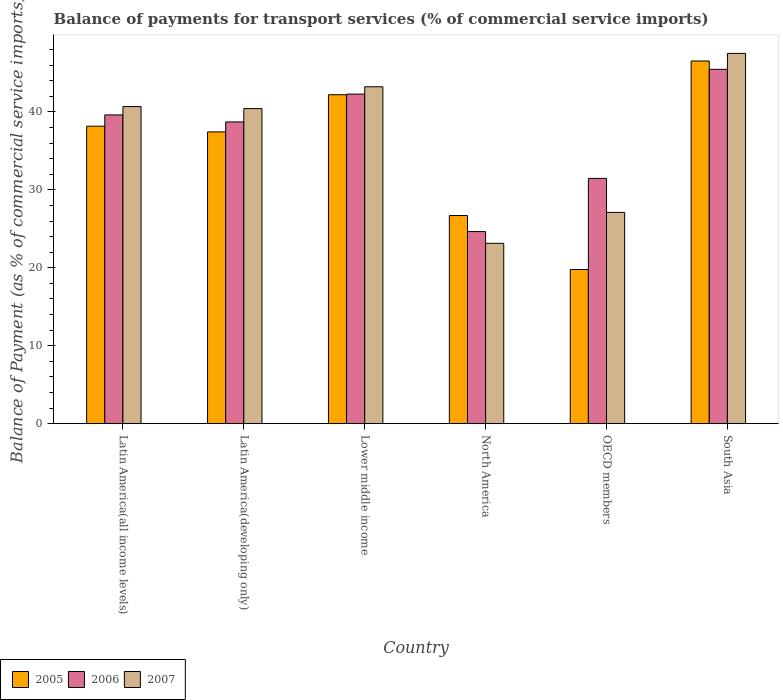Are the number of bars on each tick of the X-axis equal?
Offer a terse response. Yes. How many bars are there on the 6th tick from the left?
Offer a terse response. 3. How many bars are there on the 6th tick from the right?
Your response must be concise. 3. What is the balance of payments for transport services in 2007 in OECD members?
Make the answer very short. 27.11. Across all countries, what is the maximum balance of payments for transport services in 2007?
Provide a short and direct response. 47.5. Across all countries, what is the minimum balance of payments for transport services in 2006?
Make the answer very short. 24.65. In which country was the balance of payments for transport services in 2005 maximum?
Your answer should be compact. South Asia. What is the total balance of payments for transport services in 2005 in the graph?
Provide a short and direct response. 210.81. What is the difference between the balance of payments for transport services in 2006 in Lower middle income and that in OECD members?
Offer a terse response. 10.81. What is the difference between the balance of payments for transport services in 2006 in OECD members and the balance of payments for transport services in 2005 in Latin America(all income levels)?
Ensure brevity in your answer.  -6.7. What is the average balance of payments for transport services in 2005 per country?
Make the answer very short. 35.14. What is the difference between the balance of payments for transport services of/in 2006 and balance of payments for transport services of/in 2005 in North America?
Offer a terse response. -2.06. What is the ratio of the balance of payments for transport services in 2007 in Latin America(all income levels) to that in OECD members?
Give a very brief answer. 1.5. What is the difference between the highest and the second highest balance of payments for transport services in 2005?
Offer a terse response. -4.04. What is the difference between the highest and the lowest balance of payments for transport services in 2005?
Your response must be concise. 26.74. What does the 2nd bar from the left in South Asia represents?
Your answer should be compact. 2006. What does the 3rd bar from the right in Latin America(developing only) represents?
Make the answer very short. 2005. Are all the bars in the graph horizontal?
Your answer should be compact. No. Are the values on the major ticks of Y-axis written in scientific E-notation?
Your answer should be very brief. No. Does the graph contain any zero values?
Keep it short and to the point. No. How many legend labels are there?
Provide a short and direct response. 3. How are the legend labels stacked?
Provide a succinct answer. Horizontal. What is the title of the graph?
Offer a terse response. Balance of payments for transport services (% of commercial service imports). What is the label or title of the X-axis?
Keep it short and to the point. Country. What is the label or title of the Y-axis?
Offer a very short reply. Balance of Payment (as % of commercial service imports). What is the Balance of Payment (as % of commercial service imports) in 2005 in Latin America(all income levels)?
Offer a very short reply. 38.16. What is the Balance of Payment (as % of commercial service imports) of 2006 in Latin America(all income levels)?
Your answer should be very brief. 39.61. What is the Balance of Payment (as % of commercial service imports) of 2007 in Latin America(all income levels)?
Offer a very short reply. 40.68. What is the Balance of Payment (as % of commercial service imports) in 2005 in Latin America(developing only)?
Your answer should be very brief. 37.43. What is the Balance of Payment (as % of commercial service imports) of 2006 in Latin America(developing only)?
Offer a terse response. 38.71. What is the Balance of Payment (as % of commercial service imports) of 2007 in Latin America(developing only)?
Make the answer very short. 40.42. What is the Balance of Payment (as % of commercial service imports) in 2005 in Lower middle income?
Ensure brevity in your answer.  42.2. What is the Balance of Payment (as % of commercial service imports) of 2006 in Lower middle income?
Ensure brevity in your answer.  42.28. What is the Balance of Payment (as % of commercial service imports) in 2007 in Lower middle income?
Offer a very short reply. 43.22. What is the Balance of Payment (as % of commercial service imports) in 2005 in North America?
Provide a short and direct response. 26.71. What is the Balance of Payment (as % of commercial service imports) of 2006 in North America?
Offer a terse response. 24.65. What is the Balance of Payment (as % of commercial service imports) of 2007 in North America?
Provide a succinct answer. 23.14. What is the Balance of Payment (as % of commercial service imports) in 2005 in OECD members?
Your response must be concise. 19.78. What is the Balance of Payment (as % of commercial service imports) in 2006 in OECD members?
Offer a terse response. 31.47. What is the Balance of Payment (as % of commercial service imports) in 2007 in OECD members?
Your answer should be compact. 27.11. What is the Balance of Payment (as % of commercial service imports) of 2005 in South Asia?
Your response must be concise. 46.53. What is the Balance of Payment (as % of commercial service imports) in 2006 in South Asia?
Make the answer very short. 45.46. What is the Balance of Payment (as % of commercial service imports) of 2007 in South Asia?
Keep it short and to the point. 47.5. Across all countries, what is the maximum Balance of Payment (as % of commercial service imports) of 2005?
Your answer should be very brief. 46.53. Across all countries, what is the maximum Balance of Payment (as % of commercial service imports) in 2006?
Offer a very short reply. 45.46. Across all countries, what is the maximum Balance of Payment (as % of commercial service imports) in 2007?
Your response must be concise. 47.5. Across all countries, what is the minimum Balance of Payment (as % of commercial service imports) in 2005?
Offer a terse response. 19.78. Across all countries, what is the minimum Balance of Payment (as % of commercial service imports) of 2006?
Your response must be concise. 24.65. Across all countries, what is the minimum Balance of Payment (as % of commercial service imports) of 2007?
Ensure brevity in your answer.  23.14. What is the total Balance of Payment (as % of commercial service imports) of 2005 in the graph?
Offer a terse response. 210.81. What is the total Balance of Payment (as % of commercial service imports) in 2006 in the graph?
Your response must be concise. 222.17. What is the total Balance of Payment (as % of commercial service imports) in 2007 in the graph?
Keep it short and to the point. 222.07. What is the difference between the Balance of Payment (as % of commercial service imports) in 2005 in Latin America(all income levels) and that in Latin America(developing only)?
Offer a very short reply. 0.73. What is the difference between the Balance of Payment (as % of commercial service imports) in 2006 in Latin America(all income levels) and that in Latin America(developing only)?
Your answer should be very brief. 0.9. What is the difference between the Balance of Payment (as % of commercial service imports) of 2007 in Latin America(all income levels) and that in Latin America(developing only)?
Your answer should be very brief. 0.26. What is the difference between the Balance of Payment (as % of commercial service imports) in 2005 in Latin America(all income levels) and that in Lower middle income?
Offer a terse response. -4.04. What is the difference between the Balance of Payment (as % of commercial service imports) in 2006 in Latin America(all income levels) and that in Lower middle income?
Your answer should be very brief. -2.67. What is the difference between the Balance of Payment (as % of commercial service imports) in 2007 in Latin America(all income levels) and that in Lower middle income?
Offer a terse response. -2.54. What is the difference between the Balance of Payment (as % of commercial service imports) of 2005 in Latin America(all income levels) and that in North America?
Your response must be concise. 11.46. What is the difference between the Balance of Payment (as % of commercial service imports) of 2006 in Latin America(all income levels) and that in North America?
Your response must be concise. 14.96. What is the difference between the Balance of Payment (as % of commercial service imports) in 2007 in Latin America(all income levels) and that in North America?
Your answer should be very brief. 17.54. What is the difference between the Balance of Payment (as % of commercial service imports) of 2005 in Latin America(all income levels) and that in OECD members?
Your answer should be very brief. 18.38. What is the difference between the Balance of Payment (as % of commercial service imports) in 2006 in Latin America(all income levels) and that in OECD members?
Offer a terse response. 8.14. What is the difference between the Balance of Payment (as % of commercial service imports) in 2007 in Latin America(all income levels) and that in OECD members?
Offer a very short reply. 13.57. What is the difference between the Balance of Payment (as % of commercial service imports) in 2005 in Latin America(all income levels) and that in South Asia?
Provide a succinct answer. -8.36. What is the difference between the Balance of Payment (as % of commercial service imports) of 2006 in Latin America(all income levels) and that in South Asia?
Your answer should be very brief. -5.85. What is the difference between the Balance of Payment (as % of commercial service imports) of 2007 in Latin America(all income levels) and that in South Asia?
Provide a short and direct response. -6.82. What is the difference between the Balance of Payment (as % of commercial service imports) of 2005 in Latin America(developing only) and that in Lower middle income?
Give a very brief answer. -4.77. What is the difference between the Balance of Payment (as % of commercial service imports) in 2006 in Latin America(developing only) and that in Lower middle income?
Give a very brief answer. -3.57. What is the difference between the Balance of Payment (as % of commercial service imports) in 2007 in Latin America(developing only) and that in Lower middle income?
Your answer should be very brief. -2.8. What is the difference between the Balance of Payment (as % of commercial service imports) of 2005 in Latin America(developing only) and that in North America?
Your answer should be very brief. 10.73. What is the difference between the Balance of Payment (as % of commercial service imports) of 2006 in Latin America(developing only) and that in North America?
Ensure brevity in your answer.  14.06. What is the difference between the Balance of Payment (as % of commercial service imports) in 2007 in Latin America(developing only) and that in North America?
Ensure brevity in your answer.  17.28. What is the difference between the Balance of Payment (as % of commercial service imports) in 2005 in Latin America(developing only) and that in OECD members?
Keep it short and to the point. 17.65. What is the difference between the Balance of Payment (as % of commercial service imports) in 2006 in Latin America(developing only) and that in OECD members?
Your response must be concise. 7.24. What is the difference between the Balance of Payment (as % of commercial service imports) in 2007 in Latin America(developing only) and that in OECD members?
Your response must be concise. 13.31. What is the difference between the Balance of Payment (as % of commercial service imports) of 2005 in Latin America(developing only) and that in South Asia?
Give a very brief answer. -9.09. What is the difference between the Balance of Payment (as % of commercial service imports) in 2006 in Latin America(developing only) and that in South Asia?
Make the answer very short. -6.75. What is the difference between the Balance of Payment (as % of commercial service imports) of 2007 in Latin America(developing only) and that in South Asia?
Give a very brief answer. -7.08. What is the difference between the Balance of Payment (as % of commercial service imports) in 2005 in Lower middle income and that in North America?
Offer a very short reply. 15.49. What is the difference between the Balance of Payment (as % of commercial service imports) of 2006 in Lower middle income and that in North America?
Your answer should be compact. 17.63. What is the difference between the Balance of Payment (as % of commercial service imports) of 2007 in Lower middle income and that in North America?
Make the answer very short. 20.08. What is the difference between the Balance of Payment (as % of commercial service imports) in 2005 in Lower middle income and that in OECD members?
Make the answer very short. 22.42. What is the difference between the Balance of Payment (as % of commercial service imports) of 2006 in Lower middle income and that in OECD members?
Offer a terse response. 10.81. What is the difference between the Balance of Payment (as % of commercial service imports) of 2007 in Lower middle income and that in OECD members?
Offer a terse response. 16.11. What is the difference between the Balance of Payment (as % of commercial service imports) in 2005 in Lower middle income and that in South Asia?
Your response must be concise. -4.32. What is the difference between the Balance of Payment (as % of commercial service imports) in 2006 in Lower middle income and that in South Asia?
Keep it short and to the point. -3.18. What is the difference between the Balance of Payment (as % of commercial service imports) in 2007 in Lower middle income and that in South Asia?
Offer a very short reply. -4.28. What is the difference between the Balance of Payment (as % of commercial service imports) in 2005 in North America and that in OECD members?
Your answer should be compact. 6.93. What is the difference between the Balance of Payment (as % of commercial service imports) in 2006 in North America and that in OECD members?
Give a very brief answer. -6.82. What is the difference between the Balance of Payment (as % of commercial service imports) of 2007 in North America and that in OECD members?
Provide a short and direct response. -3.97. What is the difference between the Balance of Payment (as % of commercial service imports) in 2005 in North America and that in South Asia?
Provide a succinct answer. -19.82. What is the difference between the Balance of Payment (as % of commercial service imports) of 2006 in North America and that in South Asia?
Make the answer very short. -20.81. What is the difference between the Balance of Payment (as % of commercial service imports) in 2007 in North America and that in South Asia?
Provide a short and direct response. -24.36. What is the difference between the Balance of Payment (as % of commercial service imports) of 2005 in OECD members and that in South Asia?
Give a very brief answer. -26.74. What is the difference between the Balance of Payment (as % of commercial service imports) in 2006 in OECD members and that in South Asia?
Keep it short and to the point. -13.99. What is the difference between the Balance of Payment (as % of commercial service imports) in 2007 in OECD members and that in South Asia?
Give a very brief answer. -20.39. What is the difference between the Balance of Payment (as % of commercial service imports) of 2005 in Latin America(all income levels) and the Balance of Payment (as % of commercial service imports) of 2006 in Latin America(developing only)?
Provide a short and direct response. -0.55. What is the difference between the Balance of Payment (as % of commercial service imports) in 2005 in Latin America(all income levels) and the Balance of Payment (as % of commercial service imports) in 2007 in Latin America(developing only)?
Offer a terse response. -2.26. What is the difference between the Balance of Payment (as % of commercial service imports) of 2006 in Latin America(all income levels) and the Balance of Payment (as % of commercial service imports) of 2007 in Latin America(developing only)?
Your answer should be very brief. -0.81. What is the difference between the Balance of Payment (as % of commercial service imports) of 2005 in Latin America(all income levels) and the Balance of Payment (as % of commercial service imports) of 2006 in Lower middle income?
Your response must be concise. -4.11. What is the difference between the Balance of Payment (as % of commercial service imports) of 2005 in Latin America(all income levels) and the Balance of Payment (as % of commercial service imports) of 2007 in Lower middle income?
Ensure brevity in your answer.  -5.06. What is the difference between the Balance of Payment (as % of commercial service imports) of 2006 in Latin America(all income levels) and the Balance of Payment (as % of commercial service imports) of 2007 in Lower middle income?
Your answer should be compact. -3.61. What is the difference between the Balance of Payment (as % of commercial service imports) of 2005 in Latin America(all income levels) and the Balance of Payment (as % of commercial service imports) of 2006 in North America?
Make the answer very short. 13.52. What is the difference between the Balance of Payment (as % of commercial service imports) in 2005 in Latin America(all income levels) and the Balance of Payment (as % of commercial service imports) in 2007 in North America?
Provide a short and direct response. 15.02. What is the difference between the Balance of Payment (as % of commercial service imports) in 2006 in Latin America(all income levels) and the Balance of Payment (as % of commercial service imports) in 2007 in North America?
Your answer should be very brief. 16.47. What is the difference between the Balance of Payment (as % of commercial service imports) in 2005 in Latin America(all income levels) and the Balance of Payment (as % of commercial service imports) in 2006 in OECD members?
Make the answer very short. 6.7. What is the difference between the Balance of Payment (as % of commercial service imports) in 2005 in Latin America(all income levels) and the Balance of Payment (as % of commercial service imports) in 2007 in OECD members?
Your answer should be very brief. 11.06. What is the difference between the Balance of Payment (as % of commercial service imports) in 2006 in Latin America(all income levels) and the Balance of Payment (as % of commercial service imports) in 2007 in OECD members?
Your answer should be compact. 12.5. What is the difference between the Balance of Payment (as % of commercial service imports) in 2005 in Latin America(all income levels) and the Balance of Payment (as % of commercial service imports) in 2006 in South Asia?
Keep it short and to the point. -7.29. What is the difference between the Balance of Payment (as % of commercial service imports) of 2005 in Latin America(all income levels) and the Balance of Payment (as % of commercial service imports) of 2007 in South Asia?
Your response must be concise. -9.34. What is the difference between the Balance of Payment (as % of commercial service imports) of 2006 in Latin America(all income levels) and the Balance of Payment (as % of commercial service imports) of 2007 in South Asia?
Your answer should be compact. -7.89. What is the difference between the Balance of Payment (as % of commercial service imports) of 2005 in Latin America(developing only) and the Balance of Payment (as % of commercial service imports) of 2006 in Lower middle income?
Keep it short and to the point. -4.84. What is the difference between the Balance of Payment (as % of commercial service imports) in 2005 in Latin America(developing only) and the Balance of Payment (as % of commercial service imports) in 2007 in Lower middle income?
Provide a succinct answer. -5.79. What is the difference between the Balance of Payment (as % of commercial service imports) of 2006 in Latin America(developing only) and the Balance of Payment (as % of commercial service imports) of 2007 in Lower middle income?
Your answer should be very brief. -4.51. What is the difference between the Balance of Payment (as % of commercial service imports) in 2005 in Latin America(developing only) and the Balance of Payment (as % of commercial service imports) in 2006 in North America?
Make the answer very short. 12.79. What is the difference between the Balance of Payment (as % of commercial service imports) of 2005 in Latin America(developing only) and the Balance of Payment (as % of commercial service imports) of 2007 in North America?
Your response must be concise. 14.29. What is the difference between the Balance of Payment (as % of commercial service imports) in 2006 in Latin America(developing only) and the Balance of Payment (as % of commercial service imports) in 2007 in North America?
Offer a very short reply. 15.57. What is the difference between the Balance of Payment (as % of commercial service imports) of 2005 in Latin America(developing only) and the Balance of Payment (as % of commercial service imports) of 2006 in OECD members?
Ensure brevity in your answer.  5.96. What is the difference between the Balance of Payment (as % of commercial service imports) of 2005 in Latin America(developing only) and the Balance of Payment (as % of commercial service imports) of 2007 in OECD members?
Make the answer very short. 10.33. What is the difference between the Balance of Payment (as % of commercial service imports) in 2006 in Latin America(developing only) and the Balance of Payment (as % of commercial service imports) in 2007 in OECD members?
Ensure brevity in your answer.  11.6. What is the difference between the Balance of Payment (as % of commercial service imports) of 2005 in Latin America(developing only) and the Balance of Payment (as % of commercial service imports) of 2006 in South Asia?
Offer a terse response. -8.02. What is the difference between the Balance of Payment (as % of commercial service imports) in 2005 in Latin America(developing only) and the Balance of Payment (as % of commercial service imports) in 2007 in South Asia?
Give a very brief answer. -10.07. What is the difference between the Balance of Payment (as % of commercial service imports) in 2006 in Latin America(developing only) and the Balance of Payment (as % of commercial service imports) in 2007 in South Asia?
Your answer should be compact. -8.79. What is the difference between the Balance of Payment (as % of commercial service imports) in 2005 in Lower middle income and the Balance of Payment (as % of commercial service imports) in 2006 in North America?
Provide a succinct answer. 17.55. What is the difference between the Balance of Payment (as % of commercial service imports) in 2005 in Lower middle income and the Balance of Payment (as % of commercial service imports) in 2007 in North America?
Your answer should be compact. 19.06. What is the difference between the Balance of Payment (as % of commercial service imports) in 2006 in Lower middle income and the Balance of Payment (as % of commercial service imports) in 2007 in North America?
Provide a succinct answer. 19.14. What is the difference between the Balance of Payment (as % of commercial service imports) in 2005 in Lower middle income and the Balance of Payment (as % of commercial service imports) in 2006 in OECD members?
Keep it short and to the point. 10.73. What is the difference between the Balance of Payment (as % of commercial service imports) in 2005 in Lower middle income and the Balance of Payment (as % of commercial service imports) in 2007 in OECD members?
Your answer should be compact. 15.09. What is the difference between the Balance of Payment (as % of commercial service imports) in 2006 in Lower middle income and the Balance of Payment (as % of commercial service imports) in 2007 in OECD members?
Provide a succinct answer. 15.17. What is the difference between the Balance of Payment (as % of commercial service imports) in 2005 in Lower middle income and the Balance of Payment (as % of commercial service imports) in 2006 in South Asia?
Keep it short and to the point. -3.26. What is the difference between the Balance of Payment (as % of commercial service imports) in 2005 in Lower middle income and the Balance of Payment (as % of commercial service imports) in 2007 in South Asia?
Your answer should be compact. -5.3. What is the difference between the Balance of Payment (as % of commercial service imports) in 2006 in Lower middle income and the Balance of Payment (as % of commercial service imports) in 2007 in South Asia?
Give a very brief answer. -5.22. What is the difference between the Balance of Payment (as % of commercial service imports) of 2005 in North America and the Balance of Payment (as % of commercial service imports) of 2006 in OECD members?
Your response must be concise. -4.76. What is the difference between the Balance of Payment (as % of commercial service imports) of 2005 in North America and the Balance of Payment (as % of commercial service imports) of 2007 in OECD members?
Your answer should be compact. -0.4. What is the difference between the Balance of Payment (as % of commercial service imports) of 2006 in North America and the Balance of Payment (as % of commercial service imports) of 2007 in OECD members?
Your answer should be compact. -2.46. What is the difference between the Balance of Payment (as % of commercial service imports) of 2005 in North America and the Balance of Payment (as % of commercial service imports) of 2006 in South Asia?
Provide a short and direct response. -18.75. What is the difference between the Balance of Payment (as % of commercial service imports) in 2005 in North America and the Balance of Payment (as % of commercial service imports) in 2007 in South Asia?
Make the answer very short. -20.79. What is the difference between the Balance of Payment (as % of commercial service imports) of 2006 in North America and the Balance of Payment (as % of commercial service imports) of 2007 in South Asia?
Offer a terse response. -22.85. What is the difference between the Balance of Payment (as % of commercial service imports) in 2005 in OECD members and the Balance of Payment (as % of commercial service imports) in 2006 in South Asia?
Your response must be concise. -25.67. What is the difference between the Balance of Payment (as % of commercial service imports) in 2005 in OECD members and the Balance of Payment (as % of commercial service imports) in 2007 in South Asia?
Provide a short and direct response. -27.72. What is the difference between the Balance of Payment (as % of commercial service imports) of 2006 in OECD members and the Balance of Payment (as % of commercial service imports) of 2007 in South Asia?
Make the answer very short. -16.03. What is the average Balance of Payment (as % of commercial service imports) in 2005 per country?
Ensure brevity in your answer.  35.14. What is the average Balance of Payment (as % of commercial service imports) of 2006 per country?
Your response must be concise. 37.03. What is the average Balance of Payment (as % of commercial service imports) in 2007 per country?
Offer a very short reply. 37.01. What is the difference between the Balance of Payment (as % of commercial service imports) of 2005 and Balance of Payment (as % of commercial service imports) of 2006 in Latin America(all income levels)?
Offer a terse response. -1.45. What is the difference between the Balance of Payment (as % of commercial service imports) in 2005 and Balance of Payment (as % of commercial service imports) in 2007 in Latin America(all income levels)?
Ensure brevity in your answer.  -2.51. What is the difference between the Balance of Payment (as % of commercial service imports) of 2006 and Balance of Payment (as % of commercial service imports) of 2007 in Latin America(all income levels)?
Provide a short and direct response. -1.07. What is the difference between the Balance of Payment (as % of commercial service imports) of 2005 and Balance of Payment (as % of commercial service imports) of 2006 in Latin America(developing only)?
Offer a very short reply. -1.28. What is the difference between the Balance of Payment (as % of commercial service imports) in 2005 and Balance of Payment (as % of commercial service imports) in 2007 in Latin America(developing only)?
Ensure brevity in your answer.  -2.99. What is the difference between the Balance of Payment (as % of commercial service imports) in 2006 and Balance of Payment (as % of commercial service imports) in 2007 in Latin America(developing only)?
Offer a terse response. -1.71. What is the difference between the Balance of Payment (as % of commercial service imports) of 2005 and Balance of Payment (as % of commercial service imports) of 2006 in Lower middle income?
Provide a succinct answer. -0.08. What is the difference between the Balance of Payment (as % of commercial service imports) in 2005 and Balance of Payment (as % of commercial service imports) in 2007 in Lower middle income?
Make the answer very short. -1.02. What is the difference between the Balance of Payment (as % of commercial service imports) of 2006 and Balance of Payment (as % of commercial service imports) of 2007 in Lower middle income?
Ensure brevity in your answer.  -0.94. What is the difference between the Balance of Payment (as % of commercial service imports) of 2005 and Balance of Payment (as % of commercial service imports) of 2006 in North America?
Your answer should be very brief. 2.06. What is the difference between the Balance of Payment (as % of commercial service imports) of 2005 and Balance of Payment (as % of commercial service imports) of 2007 in North America?
Your response must be concise. 3.57. What is the difference between the Balance of Payment (as % of commercial service imports) in 2006 and Balance of Payment (as % of commercial service imports) in 2007 in North America?
Keep it short and to the point. 1.51. What is the difference between the Balance of Payment (as % of commercial service imports) of 2005 and Balance of Payment (as % of commercial service imports) of 2006 in OECD members?
Your response must be concise. -11.69. What is the difference between the Balance of Payment (as % of commercial service imports) in 2005 and Balance of Payment (as % of commercial service imports) in 2007 in OECD members?
Provide a succinct answer. -7.33. What is the difference between the Balance of Payment (as % of commercial service imports) in 2006 and Balance of Payment (as % of commercial service imports) in 2007 in OECD members?
Your answer should be compact. 4.36. What is the difference between the Balance of Payment (as % of commercial service imports) of 2005 and Balance of Payment (as % of commercial service imports) of 2006 in South Asia?
Give a very brief answer. 1.07. What is the difference between the Balance of Payment (as % of commercial service imports) in 2005 and Balance of Payment (as % of commercial service imports) in 2007 in South Asia?
Provide a succinct answer. -0.98. What is the difference between the Balance of Payment (as % of commercial service imports) in 2006 and Balance of Payment (as % of commercial service imports) in 2007 in South Asia?
Offer a very short reply. -2.05. What is the ratio of the Balance of Payment (as % of commercial service imports) of 2005 in Latin America(all income levels) to that in Latin America(developing only)?
Provide a succinct answer. 1.02. What is the ratio of the Balance of Payment (as % of commercial service imports) of 2006 in Latin America(all income levels) to that in Latin America(developing only)?
Provide a succinct answer. 1.02. What is the ratio of the Balance of Payment (as % of commercial service imports) in 2007 in Latin America(all income levels) to that in Latin America(developing only)?
Provide a succinct answer. 1.01. What is the ratio of the Balance of Payment (as % of commercial service imports) in 2005 in Latin America(all income levels) to that in Lower middle income?
Keep it short and to the point. 0.9. What is the ratio of the Balance of Payment (as % of commercial service imports) of 2006 in Latin America(all income levels) to that in Lower middle income?
Give a very brief answer. 0.94. What is the ratio of the Balance of Payment (as % of commercial service imports) in 2007 in Latin America(all income levels) to that in Lower middle income?
Your answer should be compact. 0.94. What is the ratio of the Balance of Payment (as % of commercial service imports) of 2005 in Latin America(all income levels) to that in North America?
Provide a succinct answer. 1.43. What is the ratio of the Balance of Payment (as % of commercial service imports) of 2006 in Latin America(all income levels) to that in North America?
Make the answer very short. 1.61. What is the ratio of the Balance of Payment (as % of commercial service imports) of 2007 in Latin America(all income levels) to that in North America?
Your response must be concise. 1.76. What is the ratio of the Balance of Payment (as % of commercial service imports) in 2005 in Latin America(all income levels) to that in OECD members?
Give a very brief answer. 1.93. What is the ratio of the Balance of Payment (as % of commercial service imports) in 2006 in Latin America(all income levels) to that in OECD members?
Provide a short and direct response. 1.26. What is the ratio of the Balance of Payment (as % of commercial service imports) in 2007 in Latin America(all income levels) to that in OECD members?
Your answer should be compact. 1.5. What is the ratio of the Balance of Payment (as % of commercial service imports) of 2005 in Latin America(all income levels) to that in South Asia?
Ensure brevity in your answer.  0.82. What is the ratio of the Balance of Payment (as % of commercial service imports) in 2006 in Latin America(all income levels) to that in South Asia?
Your response must be concise. 0.87. What is the ratio of the Balance of Payment (as % of commercial service imports) in 2007 in Latin America(all income levels) to that in South Asia?
Offer a terse response. 0.86. What is the ratio of the Balance of Payment (as % of commercial service imports) in 2005 in Latin America(developing only) to that in Lower middle income?
Your response must be concise. 0.89. What is the ratio of the Balance of Payment (as % of commercial service imports) of 2006 in Latin America(developing only) to that in Lower middle income?
Provide a succinct answer. 0.92. What is the ratio of the Balance of Payment (as % of commercial service imports) in 2007 in Latin America(developing only) to that in Lower middle income?
Your answer should be very brief. 0.94. What is the ratio of the Balance of Payment (as % of commercial service imports) of 2005 in Latin America(developing only) to that in North America?
Keep it short and to the point. 1.4. What is the ratio of the Balance of Payment (as % of commercial service imports) in 2006 in Latin America(developing only) to that in North America?
Your answer should be compact. 1.57. What is the ratio of the Balance of Payment (as % of commercial service imports) of 2007 in Latin America(developing only) to that in North America?
Offer a terse response. 1.75. What is the ratio of the Balance of Payment (as % of commercial service imports) of 2005 in Latin America(developing only) to that in OECD members?
Ensure brevity in your answer.  1.89. What is the ratio of the Balance of Payment (as % of commercial service imports) of 2006 in Latin America(developing only) to that in OECD members?
Provide a short and direct response. 1.23. What is the ratio of the Balance of Payment (as % of commercial service imports) in 2007 in Latin America(developing only) to that in OECD members?
Your answer should be compact. 1.49. What is the ratio of the Balance of Payment (as % of commercial service imports) of 2005 in Latin America(developing only) to that in South Asia?
Offer a terse response. 0.8. What is the ratio of the Balance of Payment (as % of commercial service imports) of 2006 in Latin America(developing only) to that in South Asia?
Offer a terse response. 0.85. What is the ratio of the Balance of Payment (as % of commercial service imports) in 2007 in Latin America(developing only) to that in South Asia?
Provide a succinct answer. 0.85. What is the ratio of the Balance of Payment (as % of commercial service imports) of 2005 in Lower middle income to that in North America?
Your answer should be compact. 1.58. What is the ratio of the Balance of Payment (as % of commercial service imports) in 2006 in Lower middle income to that in North America?
Provide a short and direct response. 1.72. What is the ratio of the Balance of Payment (as % of commercial service imports) of 2007 in Lower middle income to that in North America?
Your response must be concise. 1.87. What is the ratio of the Balance of Payment (as % of commercial service imports) in 2005 in Lower middle income to that in OECD members?
Your answer should be very brief. 2.13. What is the ratio of the Balance of Payment (as % of commercial service imports) of 2006 in Lower middle income to that in OECD members?
Give a very brief answer. 1.34. What is the ratio of the Balance of Payment (as % of commercial service imports) of 2007 in Lower middle income to that in OECD members?
Ensure brevity in your answer.  1.59. What is the ratio of the Balance of Payment (as % of commercial service imports) in 2005 in Lower middle income to that in South Asia?
Give a very brief answer. 0.91. What is the ratio of the Balance of Payment (as % of commercial service imports) of 2006 in Lower middle income to that in South Asia?
Your answer should be compact. 0.93. What is the ratio of the Balance of Payment (as % of commercial service imports) in 2007 in Lower middle income to that in South Asia?
Make the answer very short. 0.91. What is the ratio of the Balance of Payment (as % of commercial service imports) of 2005 in North America to that in OECD members?
Ensure brevity in your answer.  1.35. What is the ratio of the Balance of Payment (as % of commercial service imports) of 2006 in North America to that in OECD members?
Provide a short and direct response. 0.78. What is the ratio of the Balance of Payment (as % of commercial service imports) in 2007 in North America to that in OECD members?
Provide a succinct answer. 0.85. What is the ratio of the Balance of Payment (as % of commercial service imports) in 2005 in North America to that in South Asia?
Ensure brevity in your answer.  0.57. What is the ratio of the Balance of Payment (as % of commercial service imports) in 2006 in North America to that in South Asia?
Keep it short and to the point. 0.54. What is the ratio of the Balance of Payment (as % of commercial service imports) of 2007 in North America to that in South Asia?
Provide a short and direct response. 0.49. What is the ratio of the Balance of Payment (as % of commercial service imports) of 2005 in OECD members to that in South Asia?
Your response must be concise. 0.43. What is the ratio of the Balance of Payment (as % of commercial service imports) in 2006 in OECD members to that in South Asia?
Make the answer very short. 0.69. What is the ratio of the Balance of Payment (as % of commercial service imports) in 2007 in OECD members to that in South Asia?
Give a very brief answer. 0.57. What is the difference between the highest and the second highest Balance of Payment (as % of commercial service imports) of 2005?
Offer a terse response. 4.32. What is the difference between the highest and the second highest Balance of Payment (as % of commercial service imports) of 2006?
Offer a terse response. 3.18. What is the difference between the highest and the second highest Balance of Payment (as % of commercial service imports) of 2007?
Your answer should be compact. 4.28. What is the difference between the highest and the lowest Balance of Payment (as % of commercial service imports) in 2005?
Provide a succinct answer. 26.74. What is the difference between the highest and the lowest Balance of Payment (as % of commercial service imports) of 2006?
Provide a short and direct response. 20.81. What is the difference between the highest and the lowest Balance of Payment (as % of commercial service imports) of 2007?
Ensure brevity in your answer.  24.36. 